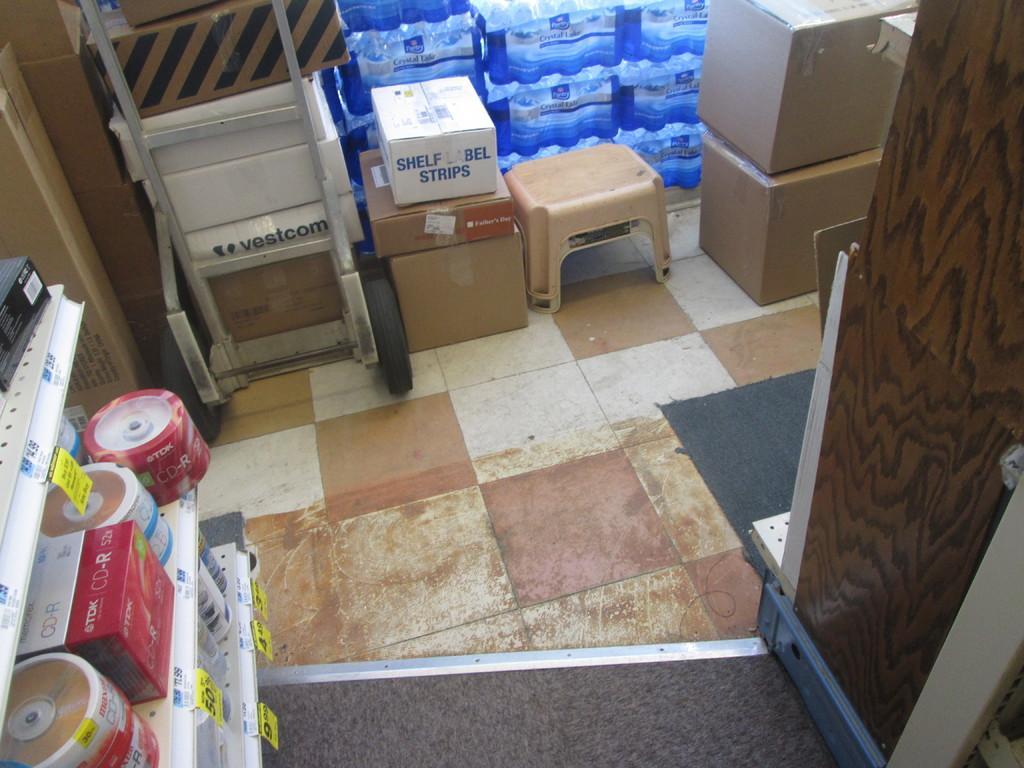Could you give a brief overview of what you see in this image? In this image I can see there see few boxes kept on the marble,and at the top I can see few boxes visible. 